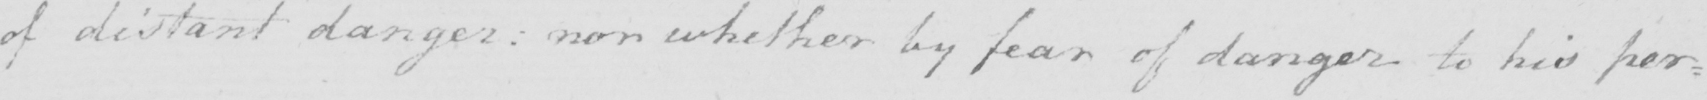Please provide the text content of this handwritten line. of distant danger: nor whether by fear of danger to his per= 